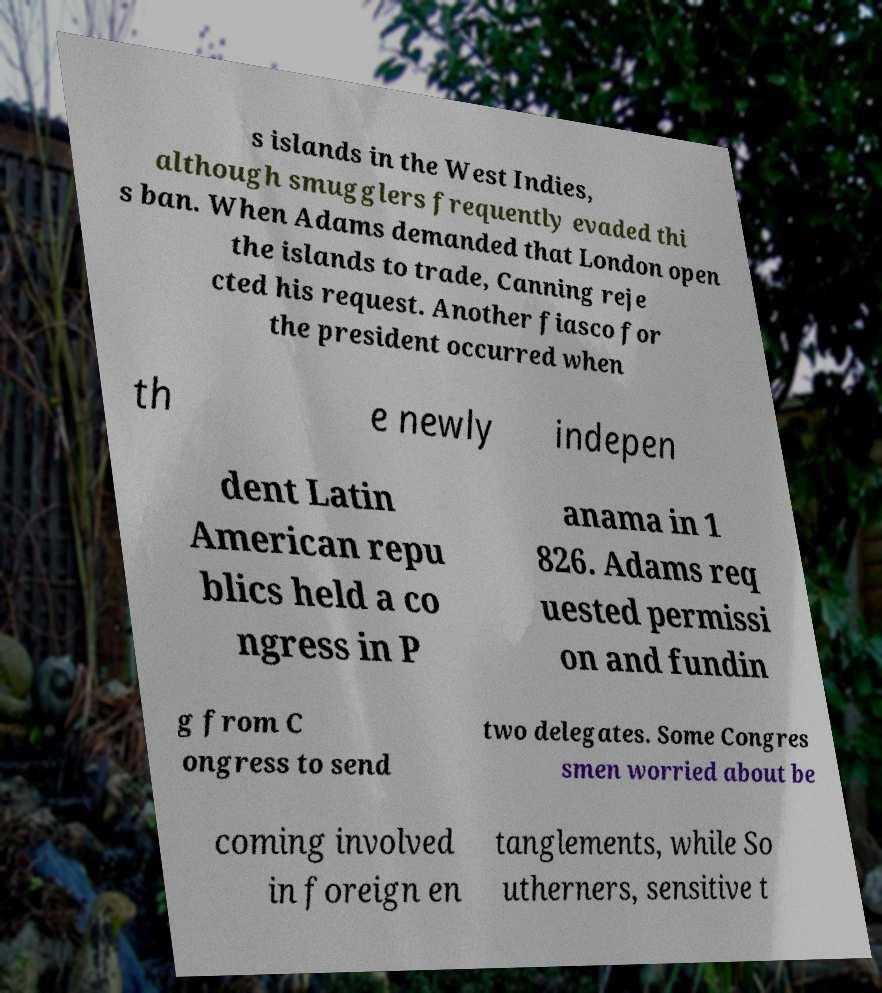Please identify and transcribe the text found in this image. s islands in the West Indies, although smugglers frequently evaded thi s ban. When Adams demanded that London open the islands to trade, Canning reje cted his request. Another fiasco for the president occurred when th e newly indepen dent Latin American repu blics held a co ngress in P anama in 1 826. Adams req uested permissi on and fundin g from C ongress to send two delegates. Some Congres smen worried about be coming involved in foreign en tanglements, while So utherners, sensitive t 